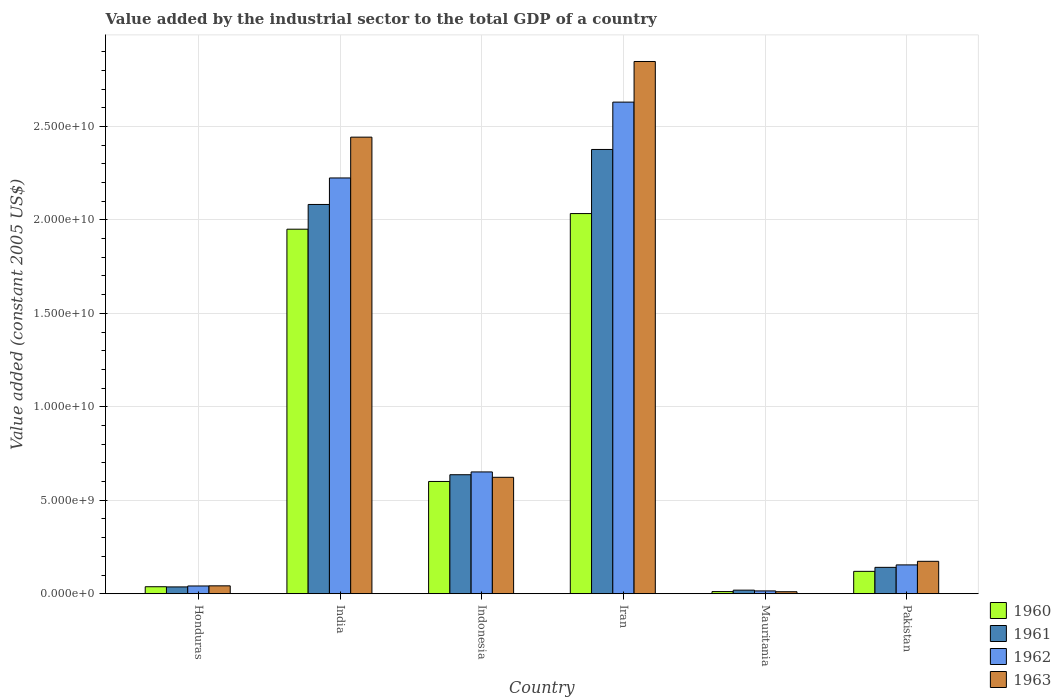How many different coloured bars are there?
Your response must be concise. 4. What is the label of the 3rd group of bars from the left?
Make the answer very short. Indonesia. What is the value added by the industrial sector in 1962 in India?
Keep it short and to the point. 2.22e+1. Across all countries, what is the maximum value added by the industrial sector in 1962?
Provide a succinct answer. 2.63e+1. Across all countries, what is the minimum value added by the industrial sector in 1960?
Give a very brief answer. 1.15e+08. In which country was the value added by the industrial sector in 1960 maximum?
Ensure brevity in your answer.  Iran. In which country was the value added by the industrial sector in 1962 minimum?
Your response must be concise. Mauritania. What is the total value added by the industrial sector in 1961 in the graph?
Give a very brief answer. 5.29e+1. What is the difference between the value added by the industrial sector in 1961 in India and that in Mauritania?
Provide a succinct answer. 2.06e+1. What is the difference between the value added by the industrial sector in 1962 in India and the value added by the industrial sector in 1961 in Honduras?
Ensure brevity in your answer.  2.19e+1. What is the average value added by the industrial sector in 1960 per country?
Offer a terse response. 7.92e+09. What is the difference between the value added by the industrial sector of/in 1961 and value added by the industrial sector of/in 1963 in Honduras?
Your response must be concise. -5.72e+07. What is the ratio of the value added by the industrial sector in 1962 in Iran to that in Mauritania?
Ensure brevity in your answer.  173.84. What is the difference between the highest and the second highest value added by the industrial sector in 1960?
Provide a short and direct response. -1.43e+1. What is the difference between the highest and the lowest value added by the industrial sector in 1961?
Ensure brevity in your answer.  2.36e+1. Is the sum of the value added by the industrial sector in 1960 in India and Pakistan greater than the maximum value added by the industrial sector in 1963 across all countries?
Your response must be concise. No. Is it the case that in every country, the sum of the value added by the industrial sector in 1963 and value added by the industrial sector in 1962 is greater than the sum of value added by the industrial sector in 1960 and value added by the industrial sector in 1961?
Give a very brief answer. No. What does the 1st bar from the right in Iran represents?
Your answer should be very brief. 1963. Is it the case that in every country, the sum of the value added by the industrial sector in 1960 and value added by the industrial sector in 1961 is greater than the value added by the industrial sector in 1963?
Your answer should be very brief. Yes. Are all the bars in the graph horizontal?
Your answer should be very brief. No. What is the difference between two consecutive major ticks on the Y-axis?
Ensure brevity in your answer.  5.00e+09. Are the values on the major ticks of Y-axis written in scientific E-notation?
Offer a very short reply. Yes. How are the legend labels stacked?
Offer a terse response. Vertical. What is the title of the graph?
Make the answer very short. Value added by the industrial sector to the total GDP of a country. Does "2011" appear as one of the legend labels in the graph?
Provide a succinct answer. No. What is the label or title of the X-axis?
Your response must be concise. Country. What is the label or title of the Y-axis?
Ensure brevity in your answer.  Value added (constant 2005 US$). What is the Value added (constant 2005 US$) in 1960 in Honduras?
Make the answer very short. 3.75e+08. What is the Value added (constant 2005 US$) in 1961 in Honduras?
Keep it short and to the point. 3.66e+08. What is the Value added (constant 2005 US$) of 1962 in Honduras?
Offer a terse response. 4.16e+08. What is the Value added (constant 2005 US$) in 1963 in Honduras?
Give a very brief answer. 4.23e+08. What is the Value added (constant 2005 US$) in 1960 in India?
Your answer should be compact. 1.95e+1. What is the Value added (constant 2005 US$) of 1961 in India?
Ensure brevity in your answer.  2.08e+1. What is the Value added (constant 2005 US$) of 1962 in India?
Ensure brevity in your answer.  2.22e+1. What is the Value added (constant 2005 US$) of 1963 in India?
Ensure brevity in your answer.  2.44e+1. What is the Value added (constant 2005 US$) of 1960 in Indonesia?
Your response must be concise. 6.01e+09. What is the Value added (constant 2005 US$) in 1961 in Indonesia?
Your answer should be very brief. 6.37e+09. What is the Value added (constant 2005 US$) in 1962 in Indonesia?
Offer a terse response. 6.52e+09. What is the Value added (constant 2005 US$) in 1963 in Indonesia?
Ensure brevity in your answer.  6.23e+09. What is the Value added (constant 2005 US$) in 1960 in Iran?
Your answer should be very brief. 2.03e+1. What is the Value added (constant 2005 US$) of 1961 in Iran?
Make the answer very short. 2.38e+1. What is the Value added (constant 2005 US$) of 1962 in Iran?
Offer a very short reply. 2.63e+1. What is the Value added (constant 2005 US$) in 1963 in Iran?
Give a very brief answer. 2.85e+1. What is the Value added (constant 2005 US$) of 1960 in Mauritania?
Provide a short and direct response. 1.15e+08. What is the Value added (constant 2005 US$) of 1961 in Mauritania?
Offer a very short reply. 1.92e+08. What is the Value added (constant 2005 US$) in 1962 in Mauritania?
Your answer should be compact. 1.51e+08. What is the Value added (constant 2005 US$) of 1963 in Mauritania?
Ensure brevity in your answer.  1.08e+08. What is the Value added (constant 2005 US$) in 1960 in Pakistan?
Make the answer very short. 1.20e+09. What is the Value added (constant 2005 US$) in 1961 in Pakistan?
Your response must be concise. 1.41e+09. What is the Value added (constant 2005 US$) of 1962 in Pakistan?
Your answer should be very brief. 1.54e+09. What is the Value added (constant 2005 US$) in 1963 in Pakistan?
Your answer should be very brief. 1.74e+09. Across all countries, what is the maximum Value added (constant 2005 US$) in 1960?
Your response must be concise. 2.03e+1. Across all countries, what is the maximum Value added (constant 2005 US$) in 1961?
Your answer should be compact. 2.38e+1. Across all countries, what is the maximum Value added (constant 2005 US$) in 1962?
Offer a very short reply. 2.63e+1. Across all countries, what is the maximum Value added (constant 2005 US$) of 1963?
Give a very brief answer. 2.85e+1. Across all countries, what is the minimum Value added (constant 2005 US$) in 1960?
Your response must be concise. 1.15e+08. Across all countries, what is the minimum Value added (constant 2005 US$) of 1961?
Offer a terse response. 1.92e+08. Across all countries, what is the minimum Value added (constant 2005 US$) of 1962?
Ensure brevity in your answer.  1.51e+08. Across all countries, what is the minimum Value added (constant 2005 US$) of 1963?
Provide a short and direct response. 1.08e+08. What is the total Value added (constant 2005 US$) of 1960 in the graph?
Make the answer very short. 4.75e+1. What is the total Value added (constant 2005 US$) of 1961 in the graph?
Give a very brief answer. 5.29e+1. What is the total Value added (constant 2005 US$) in 1962 in the graph?
Your response must be concise. 5.72e+1. What is the total Value added (constant 2005 US$) of 1963 in the graph?
Give a very brief answer. 6.14e+1. What is the difference between the Value added (constant 2005 US$) in 1960 in Honduras and that in India?
Your answer should be very brief. -1.91e+1. What is the difference between the Value added (constant 2005 US$) in 1961 in Honduras and that in India?
Your answer should be very brief. -2.05e+1. What is the difference between the Value added (constant 2005 US$) of 1962 in Honduras and that in India?
Keep it short and to the point. -2.18e+1. What is the difference between the Value added (constant 2005 US$) in 1963 in Honduras and that in India?
Provide a short and direct response. -2.40e+1. What is the difference between the Value added (constant 2005 US$) in 1960 in Honduras and that in Indonesia?
Make the answer very short. -5.63e+09. What is the difference between the Value added (constant 2005 US$) of 1961 in Honduras and that in Indonesia?
Provide a succinct answer. -6.00e+09. What is the difference between the Value added (constant 2005 US$) of 1962 in Honduras and that in Indonesia?
Your response must be concise. -6.10e+09. What is the difference between the Value added (constant 2005 US$) of 1963 in Honduras and that in Indonesia?
Provide a short and direct response. -5.81e+09. What is the difference between the Value added (constant 2005 US$) in 1960 in Honduras and that in Iran?
Your response must be concise. -2.00e+1. What is the difference between the Value added (constant 2005 US$) of 1961 in Honduras and that in Iran?
Ensure brevity in your answer.  -2.34e+1. What is the difference between the Value added (constant 2005 US$) in 1962 in Honduras and that in Iran?
Offer a very short reply. -2.59e+1. What is the difference between the Value added (constant 2005 US$) in 1963 in Honduras and that in Iran?
Your answer should be compact. -2.81e+1. What is the difference between the Value added (constant 2005 US$) in 1960 in Honduras and that in Mauritania?
Your answer should be compact. 2.60e+08. What is the difference between the Value added (constant 2005 US$) in 1961 in Honduras and that in Mauritania?
Provide a short and direct response. 1.74e+08. What is the difference between the Value added (constant 2005 US$) of 1962 in Honduras and that in Mauritania?
Provide a short and direct response. 2.65e+08. What is the difference between the Value added (constant 2005 US$) of 1963 in Honduras and that in Mauritania?
Offer a terse response. 3.15e+08. What is the difference between the Value added (constant 2005 US$) in 1960 in Honduras and that in Pakistan?
Your answer should be very brief. -8.23e+08. What is the difference between the Value added (constant 2005 US$) of 1961 in Honduras and that in Pakistan?
Provide a succinct answer. -1.05e+09. What is the difference between the Value added (constant 2005 US$) of 1962 in Honduras and that in Pakistan?
Give a very brief answer. -1.13e+09. What is the difference between the Value added (constant 2005 US$) of 1963 in Honduras and that in Pakistan?
Make the answer very short. -1.31e+09. What is the difference between the Value added (constant 2005 US$) of 1960 in India and that in Indonesia?
Keep it short and to the point. 1.35e+1. What is the difference between the Value added (constant 2005 US$) in 1961 in India and that in Indonesia?
Your response must be concise. 1.45e+1. What is the difference between the Value added (constant 2005 US$) in 1962 in India and that in Indonesia?
Offer a terse response. 1.57e+1. What is the difference between the Value added (constant 2005 US$) in 1963 in India and that in Indonesia?
Provide a short and direct response. 1.82e+1. What is the difference between the Value added (constant 2005 US$) of 1960 in India and that in Iran?
Ensure brevity in your answer.  -8.36e+08. What is the difference between the Value added (constant 2005 US$) of 1961 in India and that in Iran?
Make the answer very short. -2.94e+09. What is the difference between the Value added (constant 2005 US$) of 1962 in India and that in Iran?
Ensure brevity in your answer.  -4.06e+09. What is the difference between the Value added (constant 2005 US$) of 1963 in India and that in Iran?
Give a very brief answer. -4.05e+09. What is the difference between the Value added (constant 2005 US$) of 1960 in India and that in Mauritania?
Offer a terse response. 1.94e+1. What is the difference between the Value added (constant 2005 US$) in 1961 in India and that in Mauritania?
Provide a short and direct response. 2.06e+1. What is the difference between the Value added (constant 2005 US$) in 1962 in India and that in Mauritania?
Keep it short and to the point. 2.21e+1. What is the difference between the Value added (constant 2005 US$) in 1963 in India and that in Mauritania?
Offer a very short reply. 2.43e+1. What is the difference between the Value added (constant 2005 US$) of 1960 in India and that in Pakistan?
Ensure brevity in your answer.  1.83e+1. What is the difference between the Value added (constant 2005 US$) in 1961 in India and that in Pakistan?
Your answer should be very brief. 1.94e+1. What is the difference between the Value added (constant 2005 US$) of 1962 in India and that in Pakistan?
Provide a short and direct response. 2.07e+1. What is the difference between the Value added (constant 2005 US$) of 1963 in India and that in Pakistan?
Provide a succinct answer. 2.27e+1. What is the difference between the Value added (constant 2005 US$) in 1960 in Indonesia and that in Iran?
Your answer should be very brief. -1.43e+1. What is the difference between the Value added (constant 2005 US$) of 1961 in Indonesia and that in Iran?
Your answer should be compact. -1.74e+1. What is the difference between the Value added (constant 2005 US$) of 1962 in Indonesia and that in Iran?
Provide a succinct answer. -1.98e+1. What is the difference between the Value added (constant 2005 US$) in 1963 in Indonesia and that in Iran?
Give a very brief answer. -2.22e+1. What is the difference between the Value added (constant 2005 US$) in 1960 in Indonesia and that in Mauritania?
Keep it short and to the point. 5.89e+09. What is the difference between the Value added (constant 2005 US$) of 1961 in Indonesia and that in Mauritania?
Your answer should be compact. 6.17e+09. What is the difference between the Value added (constant 2005 US$) in 1962 in Indonesia and that in Mauritania?
Provide a succinct answer. 6.37e+09. What is the difference between the Value added (constant 2005 US$) in 1963 in Indonesia and that in Mauritania?
Offer a very short reply. 6.12e+09. What is the difference between the Value added (constant 2005 US$) in 1960 in Indonesia and that in Pakistan?
Your answer should be very brief. 4.81e+09. What is the difference between the Value added (constant 2005 US$) of 1961 in Indonesia and that in Pakistan?
Offer a terse response. 4.96e+09. What is the difference between the Value added (constant 2005 US$) in 1962 in Indonesia and that in Pakistan?
Ensure brevity in your answer.  4.97e+09. What is the difference between the Value added (constant 2005 US$) of 1963 in Indonesia and that in Pakistan?
Provide a short and direct response. 4.49e+09. What is the difference between the Value added (constant 2005 US$) of 1960 in Iran and that in Mauritania?
Your response must be concise. 2.02e+1. What is the difference between the Value added (constant 2005 US$) of 1961 in Iran and that in Mauritania?
Provide a succinct answer. 2.36e+1. What is the difference between the Value added (constant 2005 US$) in 1962 in Iran and that in Mauritania?
Provide a succinct answer. 2.62e+1. What is the difference between the Value added (constant 2005 US$) in 1963 in Iran and that in Mauritania?
Offer a terse response. 2.84e+1. What is the difference between the Value added (constant 2005 US$) of 1960 in Iran and that in Pakistan?
Ensure brevity in your answer.  1.91e+1. What is the difference between the Value added (constant 2005 US$) in 1961 in Iran and that in Pakistan?
Keep it short and to the point. 2.24e+1. What is the difference between the Value added (constant 2005 US$) of 1962 in Iran and that in Pakistan?
Keep it short and to the point. 2.48e+1. What is the difference between the Value added (constant 2005 US$) of 1963 in Iran and that in Pakistan?
Offer a very short reply. 2.67e+1. What is the difference between the Value added (constant 2005 US$) of 1960 in Mauritania and that in Pakistan?
Ensure brevity in your answer.  -1.08e+09. What is the difference between the Value added (constant 2005 US$) of 1961 in Mauritania and that in Pakistan?
Your response must be concise. -1.22e+09. What is the difference between the Value added (constant 2005 US$) of 1962 in Mauritania and that in Pakistan?
Keep it short and to the point. -1.39e+09. What is the difference between the Value added (constant 2005 US$) of 1963 in Mauritania and that in Pakistan?
Offer a terse response. -1.63e+09. What is the difference between the Value added (constant 2005 US$) in 1960 in Honduras and the Value added (constant 2005 US$) in 1961 in India?
Keep it short and to the point. -2.05e+1. What is the difference between the Value added (constant 2005 US$) in 1960 in Honduras and the Value added (constant 2005 US$) in 1962 in India?
Provide a succinct answer. -2.19e+1. What is the difference between the Value added (constant 2005 US$) in 1960 in Honduras and the Value added (constant 2005 US$) in 1963 in India?
Ensure brevity in your answer.  -2.41e+1. What is the difference between the Value added (constant 2005 US$) in 1961 in Honduras and the Value added (constant 2005 US$) in 1962 in India?
Provide a short and direct response. -2.19e+1. What is the difference between the Value added (constant 2005 US$) in 1961 in Honduras and the Value added (constant 2005 US$) in 1963 in India?
Offer a terse response. -2.41e+1. What is the difference between the Value added (constant 2005 US$) in 1962 in Honduras and the Value added (constant 2005 US$) in 1963 in India?
Provide a short and direct response. -2.40e+1. What is the difference between the Value added (constant 2005 US$) of 1960 in Honduras and the Value added (constant 2005 US$) of 1961 in Indonesia?
Ensure brevity in your answer.  -5.99e+09. What is the difference between the Value added (constant 2005 US$) of 1960 in Honduras and the Value added (constant 2005 US$) of 1962 in Indonesia?
Provide a short and direct response. -6.14e+09. What is the difference between the Value added (constant 2005 US$) of 1960 in Honduras and the Value added (constant 2005 US$) of 1963 in Indonesia?
Your answer should be compact. -5.85e+09. What is the difference between the Value added (constant 2005 US$) in 1961 in Honduras and the Value added (constant 2005 US$) in 1962 in Indonesia?
Your response must be concise. -6.15e+09. What is the difference between the Value added (constant 2005 US$) in 1961 in Honduras and the Value added (constant 2005 US$) in 1963 in Indonesia?
Offer a terse response. -5.86e+09. What is the difference between the Value added (constant 2005 US$) of 1962 in Honduras and the Value added (constant 2005 US$) of 1963 in Indonesia?
Give a very brief answer. -5.81e+09. What is the difference between the Value added (constant 2005 US$) in 1960 in Honduras and the Value added (constant 2005 US$) in 1961 in Iran?
Give a very brief answer. -2.34e+1. What is the difference between the Value added (constant 2005 US$) in 1960 in Honduras and the Value added (constant 2005 US$) in 1962 in Iran?
Provide a short and direct response. -2.59e+1. What is the difference between the Value added (constant 2005 US$) in 1960 in Honduras and the Value added (constant 2005 US$) in 1963 in Iran?
Provide a succinct answer. -2.81e+1. What is the difference between the Value added (constant 2005 US$) of 1961 in Honduras and the Value added (constant 2005 US$) of 1962 in Iran?
Give a very brief answer. -2.59e+1. What is the difference between the Value added (constant 2005 US$) in 1961 in Honduras and the Value added (constant 2005 US$) in 1963 in Iran?
Provide a short and direct response. -2.81e+1. What is the difference between the Value added (constant 2005 US$) in 1962 in Honduras and the Value added (constant 2005 US$) in 1963 in Iran?
Give a very brief answer. -2.81e+1. What is the difference between the Value added (constant 2005 US$) in 1960 in Honduras and the Value added (constant 2005 US$) in 1961 in Mauritania?
Keep it short and to the point. 1.83e+08. What is the difference between the Value added (constant 2005 US$) of 1960 in Honduras and the Value added (constant 2005 US$) of 1962 in Mauritania?
Give a very brief answer. 2.24e+08. What is the difference between the Value added (constant 2005 US$) in 1960 in Honduras and the Value added (constant 2005 US$) in 1963 in Mauritania?
Provide a short and direct response. 2.67e+08. What is the difference between the Value added (constant 2005 US$) in 1961 in Honduras and the Value added (constant 2005 US$) in 1962 in Mauritania?
Provide a succinct answer. 2.15e+08. What is the difference between the Value added (constant 2005 US$) in 1961 in Honduras and the Value added (constant 2005 US$) in 1963 in Mauritania?
Your answer should be very brief. 2.58e+08. What is the difference between the Value added (constant 2005 US$) of 1962 in Honduras and the Value added (constant 2005 US$) of 1963 in Mauritania?
Your answer should be compact. 3.08e+08. What is the difference between the Value added (constant 2005 US$) in 1960 in Honduras and the Value added (constant 2005 US$) in 1961 in Pakistan?
Offer a terse response. -1.04e+09. What is the difference between the Value added (constant 2005 US$) in 1960 in Honduras and the Value added (constant 2005 US$) in 1962 in Pakistan?
Provide a short and direct response. -1.17e+09. What is the difference between the Value added (constant 2005 US$) in 1960 in Honduras and the Value added (constant 2005 US$) in 1963 in Pakistan?
Give a very brief answer. -1.36e+09. What is the difference between the Value added (constant 2005 US$) of 1961 in Honduras and the Value added (constant 2005 US$) of 1962 in Pakistan?
Your response must be concise. -1.18e+09. What is the difference between the Value added (constant 2005 US$) of 1961 in Honduras and the Value added (constant 2005 US$) of 1963 in Pakistan?
Give a very brief answer. -1.37e+09. What is the difference between the Value added (constant 2005 US$) in 1962 in Honduras and the Value added (constant 2005 US$) in 1963 in Pakistan?
Give a very brief answer. -1.32e+09. What is the difference between the Value added (constant 2005 US$) in 1960 in India and the Value added (constant 2005 US$) in 1961 in Indonesia?
Offer a very short reply. 1.31e+1. What is the difference between the Value added (constant 2005 US$) of 1960 in India and the Value added (constant 2005 US$) of 1962 in Indonesia?
Provide a short and direct response. 1.30e+1. What is the difference between the Value added (constant 2005 US$) of 1960 in India and the Value added (constant 2005 US$) of 1963 in Indonesia?
Make the answer very short. 1.33e+1. What is the difference between the Value added (constant 2005 US$) of 1961 in India and the Value added (constant 2005 US$) of 1962 in Indonesia?
Your answer should be compact. 1.43e+1. What is the difference between the Value added (constant 2005 US$) in 1961 in India and the Value added (constant 2005 US$) in 1963 in Indonesia?
Keep it short and to the point. 1.46e+1. What is the difference between the Value added (constant 2005 US$) of 1962 in India and the Value added (constant 2005 US$) of 1963 in Indonesia?
Ensure brevity in your answer.  1.60e+1. What is the difference between the Value added (constant 2005 US$) of 1960 in India and the Value added (constant 2005 US$) of 1961 in Iran?
Make the answer very short. -4.27e+09. What is the difference between the Value added (constant 2005 US$) in 1960 in India and the Value added (constant 2005 US$) in 1962 in Iran?
Offer a terse response. -6.80e+09. What is the difference between the Value added (constant 2005 US$) in 1960 in India and the Value added (constant 2005 US$) in 1963 in Iran?
Your answer should be very brief. -8.97e+09. What is the difference between the Value added (constant 2005 US$) in 1961 in India and the Value added (constant 2005 US$) in 1962 in Iran?
Give a very brief answer. -5.48e+09. What is the difference between the Value added (constant 2005 US$) in 1961 in India and the Value added (constant 2005 US$) in 1963 in Iran?
Your answer should be very brief. -7.65e+09. What is the difference between the Value added (constant 2005 US$) in 1962 in India and the Value added (constant 2005 US$) in 1963 in Iran?
Keep it short and to the point. -6.23e+09. What is the difference between the Value added (constant 2005 US$) in 1960 in India and the Value added (constant 2005 US$) in 1961 in Mauritania?
Your answer should be compact. 1.93e+1. What is the difference between the Value added (constant 2005 US$) in 1960 in India and the Value added (constant 2005 US$) in 1962 in Mauritania?
Give a very brief answer. 1.94e+1. What is the difference between the Value added (constant 2005 US$) of 1960 in India and the Value added (constant 2005 US$) of 1963 in Mauritania?
Offer a very short reply. 1.94e+1. What is the difference between the Value added (constant 2005 US$) of 1961 in India and the Value added (constant 2005 US$) of 1962 in Mauritania?
Give a very brief answer. 2.07e+1. What is the difference between the Value added (constant 2005 US$) in 1961 in India and the Value added (constant 2005 US$) in 1963 in Mauritania?
Provide a short and direct response. 2.07e+1. What is the difference between the Value added (constant 2005 US$) of 1962 in India and the Value added (constant 2005 US$) of 1963 in Mauritania?
Your answer should be very brief. 2.21e+1. What is the difference between the Value added (constant 2005 US$) of 1960 in India and the Value added (constant 2005 US$) of 1961 in Pakistan?
Provide a short and direct response. 1.81e+1. What is the difference between the Value added (constant 2005 US$) in 1960 in India and the Value added (constant 2005 US$) in 1962 in Pakistan?
Your answer should be very brief. 1.80e+1. What is the difference between the Value added (constant 2005 US$) in 1960 in India and the Value added (constant 2005 US$) in 1963 in Pakistan?
Make the answer very short. 1.78e+1. What is the difference between the Value added (constant 2005 US$) of 1961 in India and the Value added (constant 2005 US$) of 1962 in Pakistan?
Make the answer very short. 1.93e+1. What is the difference between the Value added (constant 2005 US$) of 1961 in India and the Value added (constant 2005 US$) of 1963 in Pakistan?
Keep it short and to the point. 1.91e+1. What is the difference between the Value added (constant 2005 US$) in 1962 in India and the Value added (constant 2005 US$) in 1963 in Pakistan?
Provide a succinct answer. 2.05e+1. What is the difference between the Value added (constant 2005 US$) of 1960 in Indonesia and the Value added (constant 2005 US$) of 1961 in Iran?
Your response must be concise. -1.78e+1. What is the difference between the Value added (constant 2005 US$) of 1960 in Indonesia and the Value added (constant 2005 US$) of 1962 in Iran?
Provide a succinct answer. -2.03e+1. What is the difference between the Value added (constant 2005 US$) in 1960 in Indonesia and the Value added (constant 2005 US$) in 1963 in Iran?
Give a very brief answer. -2.25e+1. What is the difference between the Value added (constant 2005 US$) of 1961 in Indonesia and the Value added (constant 2005 US$) of 1962 in Iran?
Provide a short and direct response. -1.99e+1. What is the difference between the Value added (constant 2005 US$) of 1961 in Indonesia and the Value added (constant 2005 US$) of 1963 in Iran?
Offer a terse response. -2.21e+1. What is the difference between the Value added (constant 2005 US$) in 1962 in Indonesia and the Value added (constant 2005 US$) in 1963 in Iran?
Provide a short and direct response. -2.20e+1. What is the difference between the Value added (constant 2005 US$) of 1960 in Indonesia and the Value added (constant 2005 US$) of 1961 in Mauritania?
Give a very brief answer. 5.81e+09. What is the difference between the Value added (constant 2005 US$) of 1960 in Indonesia and the Value added (constant 2005 US$) of 1962 in Mauritania?
Keep it short and to the point. 5.86e+09. What is the difference between the Value added (constant 2005 US$) of 1960 in Indonesia and the Value added (constant 2005 US$) of 1963 in Mauritania?
Your response must be concise. 5.90e+09. What is the difference between the Value added (constant 2005 US$) in 1961 in Indonesia and the Value added (constant 2005 US$) in 1962 in Mauritania?
Keep it short and to the point. 6.22e+09. What is the difference between the Value added (constant 2005 US$) in 1961 in Indonesia and the Value added (constant 2005 US$) in 1963 in Mauritania?
Your answer should be compact. 6.26e+09. What is the difference between the Value added (constant 2005 US$) of 1962 in Indonesia and the Value added (constant 2005 US$) of 1963 in Mauritania?
Your answer should be very brief. 6.41e+09. What is the difference between the Value added (constant 2005 US$) in 1960 in Indonesia and the Value added (constant 2005 US$) in 1961 in Pakistan?
Make the answer very short. 4.60e+09. What is the difference between the Value added (constant 2005 US$) of 1960 in Indonesia and the Value added (constant 2005 US$) of 1962 in Pakistan?
Ensure brevity in your answer.  4.46e+09. What is the difference between the Value added (constant 2005 US$) of 1960 in Indonesia and the Value added (constant 2005 US$) of 1963 in Pakistan?
Provide a short and direct response. 4.27e+09. What is the difference between the Value added (constant 2005 US$) in 1961 in Indonesia and the Value added (constant 2005 US$) in 1962 in Pakistan?
Your answer should be very brief. 4.82e+09. What is the difference between the Value added (constant 2005 US$) of 1961 in Indonesia and the Value added (constant 2005 US$) of 1963 in Pakistan?
Keep it short and to the point. 4.63e+09. What is the difference between the Value added (constant 2005 US$) in 1962 in Indonesia and the Value added (constant 2005 US$) in 1963 in Pakistan?
Offer a very short reply. 4.78e+09. What is the difference between the Value added (constant 2005 US$) in 1960 in Iran and the Value added (constant 2005 US$) in 1961 in Mauritania?
Offer a terse response. 2.01e+1. What is the difference between the Value added (constant 2005 US$) in 1960 in Iran and the Value added (constant 2005 US$) in 1962 in Mauritania?
Your answer should be very brief. 2.02e+1. What is the difference between the Value added (constant 2005 US$) of 1960 in Iran and the Value added (constant 2005 US$) of 1963 in Mauritania?
Offer a terse response. 2.02e+1. What is the difference between the Value added (constant 2005 US$) of 1961 in Iran and the Value added (constant 2005 US$) of 1962 in Mauritania?
Your answer should be compact. 2.36e+1. What is the difference between the Value added (constant 2005 US$) in 1961 in Iran and the Value added (constant 2005 US$) in 1963 in Mauritania?
Your answer should be compact. 2.37e+1. What is the difference between the Value added (constant 2005 US$) in 1962 in Iran and the Value added (constant 2005 US$) in 1963 in Mauritania?
Your answer should be very brief. 2.62e+1. What is the difference between the Value added (constant 2005 US$) in 1960 in Iran and the Value added (constant 2005 US$) in 1961 in Pakistan?
Offer a terse response. 1.89e+1. What is the difference between the Value added (constant 2005 US$) in 1960 in Iran and the Value added (constant 2005 US$) in 1962 in Pakistan?
Provide a succinct answer. 1.88e+1. What is the difference between the Value added (constant 2005 US$) in 1960 in Iran and the Value added (constant 2005 US$) in 1963 in Pakistan?
Ensure brevity in your answer.  1.86e+1. What is the difference between the Value added (constant 2005 US$) in 1961 in Iran and the Value added (constant 2005 US$) in 1962 in Pakistan?
Make the answer very short. 2.22e+1. What is the difference between the Value added (constant 2005 US$) of 1961 in Iran and the Value added (constant 2005 US$) of 1963 in Pakistan?
Ensure brevity in your answer.  2.20e+1. What is the difference between the Value added (constant 2005 US$) of 1962 in Iran and the Value added (constant 2005 US$) of 1963 in Pakistan?
Your answer should be compact. 2.46e+1. What is the difference between the Value added (constant 2005 US$) of 1960 in Mauritania and the Value added (constant 2005 US$) of 1961 in Pakistan?
Your answer should be compact. -1.30e+09. What is the difference between the Value added (constant 2005 US$) in 1960 in Mauritania and the Value added (constant 2005 US$) in 1962 in Pakistan?
Offer a terse response. -1.43e+09. What is the difference between the Value added (constant 2005 US$) in 1960 in Mauritania and the Value added (constant 2005 US$) in 1963 in Pakistan?
Offer a terse response. -1.62e+09. What is the difference between the Value added (constant 2005 US$) in 1961 in Mauritania and the Value added (constant 2005 US$) in 1962 in Pakistan?
Provide a succinct answer. -1.35e+09. What is the difference between the Value added (constant 2005 US$) of 1961 in Mauritania and the Value added (constant 2005 US$) of 1963 in Pakistan?
Provide a short and direct response. -1.54e+09. What is the difference between the Value added (constant 2005 US$) of 1962 in Mauritania and the Value added (constant 2005 US$) of 1963 in Pakistan?
Provide a short and direct response. -1.58e+09. What is the average Value added (constant 2005 US$) of 1960 per country?
Your response must be concise. 7.92e+09. What is the average Value added (constant 2005 US$) in 1961 per country?
Ensure brevity in your answer.  8.82e+09. What is the average Value added (constant 2005 US$) in 1962 per country?
Your answer should be very brief. 9.53e+09. What is the average Value added (constant 2005 US$) in 1963 per country?
Offer a very short reply. 1.02e+1. What is the difference between the Value added (constant 2005 US$) in 1960 and Value added (constant 2005 US$) in 1961 in Honduras?
Provide a succinct answer. 9.37e+06. What is the difference between the Value added (constant 2005 US$) of 1960 and Value added (constant 2005 US$) of 1962 in Honduras?
Give a very brief answer. -4.07e+07. What is the difference between the Value added (constant 2005 US$) of 1960 and Value added (constant 2005 US$) of 1963 in Honduras?
Offer a terse response. -4.79e+07. What is the difference between the Value added (constant 2005 US$) in 1961 and Value added (constant 2005 US$) in 1962 in Honduras?
Your answer should be very brief. -5.00e+07. What is the difference between the Value added (constant 2005 US$) of 1961 and Value added (constant 2005 US$) of 1963 in Honduras?
Provide a succinct answer. -5.72e+07. What is the difference between the Value added (constant 2005 US$) in 1962 and Value added (constant 2005 US$) in 1963 in Honduras?
Your answer should be compact. -7.19e+06. What is the difference between the Value added (constant 2005 US$) in 1960 and Value added (constant 2005 US$) in 1961 in India?
Your answer should be very brief. -1.32e+09. What is the difference between the Value added (constant 2005 US$) of 1960 and Value added (constant 2005 US$) of 1962 in India?
Your answer should be compact. -2.74e+09. What is the difference between the Value added (constant 2005 US$) in 1960 and Value added (constant 2005 US$) in 1963 in India?
Your answer should be very brief. -4.92e+09. What is the difference between the Value added (constant 2005 US$) in 1961 and Value added (constant 2005 US$) in 1962 in India?
Your answer should be very brief. -1.42e+09. What is the difference between the Value added (constant 2005 US$) in 1961 and Value added (constant 2005 US$) in 1963 in India?
Offer a terse response. -3.60e+09. What is the difference between the Value added (constant 2005 US$) of 1962 and Value added (constant 2005 US$) of 1963 in India?
Provide a succinct answer. -2.18e+09. What is the difference between the Value added (constant 2005 US$) in 1960 and Value added (constant 2005 US$) in 1961 in Indonesia?
Offer a very short reply. -3.60e+08. What is the difference between the Value added (constant 2005 US$) of 1960 and Value added (constant 2005 US$) of 1962 in Indonesia?
Offer a very short reply. -5.10e+08. What is the difference between the Value added (constant 2005 US$) in 1960 and Value added (constant 2005 US$) in 1963 in Indonesia?
Your response must be concise. -2.22e+08. What is the difference between the Value added (constant 2005 US$) in 1961 and Value added (constant 2005 US$) in 1962 in Indonesia?
Provide a short and direct response. -1.50e+08. What is the difference between the Value added (constant 2005 US$) of 1961 and Value added (constant 2005 US$) of 1963 in Indonesia?
Your response must be concise. 1.38e+08. What is the difference between the Value added (constant 2005 US$) in 1962 and Value added (constant 2005 US$) in 1963 in Indonesia?
Your response must be concise. 2.88e+08. What is the difference between the Value added (constant 2005 US$) in 1960 and Value added (constant 2005 US$) in 1961 in Iran?
Provide a succinct answer. -3.43e+09. What is the difference between the Value added (constant 2005 US$) of 1960 and Value added (constant 2005 US$) of 1962 in Iran?
Provide a succinct answer. -5.96e+09. What is the difference between the Value added (constant 2005 US$) of 1960 and Value added (constant 2005 US$) of 1963 in Iran?
Make the answer very short. -8.14e+09. What is the difference between the Value added (constant 2005 US$) of 1961 and Value added (constant 2005 US$) of 1962 in Iran?
Ensure brevity in your answer.  -2.53e+09. What is the difference between the Value added (constant 2005 US$) of 1961 and Value added (constant 2005 US$) of 1963 in Iran?
Make the answer very short. -4.71e+09. What is the difference between the Value added (constant 2005 US$) in 1962 and Value added (constant 2005 US$) in 1963 in Iran?
Ensure brevity in your answer.  -2.17e+09. What is the difference between the Value added (constant 2005 US$) in 1960 and Value added (constant 2005 US$) in 1961 in Mauritania?
Your answer should be very brief. -7.68e+07. What is the difference between the Value added (constant 2005 US$) in 1960 and Value added (constant 2005 US$) in 1962 in Mauritania?
Your answer should be very brief. -3.59e+07. What is the difference between the Value added (constant 2005 US$) of 1960 and Value added (constant 2005 US$) of 1963 in Mauritania?
Offer a very short reply. 7.13e+06. What is the difference between the Value added (constant 2005 US$) of 1961 and Value added (constant 2005 US$) of 1962 in Mauritania?
Offer a very short reply. 4.09e+07. What is the difference between the Value added (constant 2005 US$) of 1961 and Value added (constant 2005 US$) of 1963 in Mauritania?
Ensure brevity in your answer.  8.39e+07. What is the difference between the Value added (constant 2005 US$) in 1962 and Value added (constant 2005 US$) in 1963 in Mauritania?
Provide a succinct answer. 4.31e+07. What is the difference between the Value added (constant 2005 US$) of 1960 and Value added (constant 2005 US$) of 1961 in Pakistan?
Give a very brief answer. -2.14e+08. What is the difference between the Value added (constant 2005 US$) of 1960 and Value added (constant 2005 US$) of 1962 in Pakistan?
Keep it short and to the point. -3.45e+08. What is the difference between the Value added (constant 2005 US$) of 1960 and Value added (constant 2005 US$) of 1963 in Pakistan?
Provide a short and direct response. -5.37e+08. What is the difference between the Value added (constant 2005 US$) of 1961 and Value added (constant 2005 US$) of 1962 in Pakistan?
Keep it short and to the point. -1.32e+08. What is the difference between the Value added (constant 2005 US$) of 1961 and Value added (constant 2005 US$) of 1963 in Pakistan?
Your response must be concise. -3.23e+08. What is the difference between the Value added (constant 2005 US$) of 1962 and Value added (constant 2005 US$) of 1963 in Pakistan?
Your answer should be very brief. -1.92e+08. What is the ratio of the Value added (constant 2005 US$) of 1960 in Honduras to that in India?
Offer a terse response. 0.02. What is the ratio of the Value added (constant 2005 US$) in 1961 in Honduras to that in India?
Give a very brief answer. 0.02. What is the ratio of the Value added (constant 2005 US$) in 1962 in Honduras to that in India?
Ensure brevity in your answer.  0.02. What is the ratio of the Value added (constant 2005 US$) of 1963 in Honduras to that in India?
Ensure brevity in your answer.  0.02. What is the ratio of the Value added (constant 2005 US$) in 1960 in Honduras to that in Indonesia?
Keep it short and to the point. 0.06. What is the ratio of the Value added (constant 2005 US$) in 1961 in Honduras to that in Indonesia?
Offer a terse response. 0.06. What is the ratio of the Value added (constant 2005 US$) of 1962 in Honduras to that in Indonesia?
Ensure brevity in your answer.  0.06. What is the ratio of the Value added (constant 2005 US$) in 1963 in Honduras to that in Indonesia?
Provide a short and direct response. 0.07. What is the ratio of the Value added (constant 2005 US$) in 1960 in Honduras to that in Iran?
Make the answer very short. 0.02. What is the ratio of the Value added (constant 2005 US$) of 1961 in Honduras to that in Iran?
Keep it short and to the point. 0.02. What is the ratio of the Value added (constant 2005 US$) in 1962 in Honduras to that in Iran?
Make the answer very short. 0.02. What is the ratio of the Value added (constant 2005 US$) of 1963 in Honduras to that in Iran?
Provide a succinct answer. 0.01. What is the ratio of the Value added (constant 2005 US$) in 1960 in Honduras to that in Mauritania?
Offer a very short reply. 3.25. What is the ratio of the Value added (constant 2005 US$) in 1961 in Honduras to that in Mauritania?
Provide a succinct answer. 1.9. What is the ratio of the Value added (constant 2005 US$) of 1962 in Honduras to that in Mauritania?
Provide a short and direct response. 2.75. What is the ratio of the Value added (constant 2005 US$) in 1963 in Honduras to that in Mauritania?
Ensure brevity in your answer.  3.91. What is the ratio of the Value added (constant 2005 US$) of 1960 in Honduras to that in Pakistan?
Provide a short and direct response. 0.31. What is the ratio of the Value added (constant 2005 US$) of 1961 in Honduras to that in Pakistan?
Keep it short and to the point. 0.26. What is the ratio of the Value added (constant 2005 US$) in 1962 in Honduras to that in Pakistan?
Provide a short and direct response. 0.27. What is the ratio of the Value added (constant 2005 US$) of 1963 in Honduras to that in Pakistan?
Your response must be concise. 0.24. What is the ratio of the Value added (constant 2005 US$) in 1960 in India to that in Indonesia?
Provide a succinct answer. 3.25. What is the ratio of the Value added (constant 2005 US$) in 1961 in India to that in Indonesia?
Keep it short and to the point. 3.27. What is the ratio of the Value added (constant 2005 US$) in 1962 in India to that in Indonesia?
Make the answer very short. 3.41. What is the ratio of the Value added (constant 2005 US$) of 1963 in India to that in Indonesia?
Your response must be concise. 3.92. What is the ratio of the Value added (constant 2005 US$) in 1960 in India to that in Iran?
Your answer should be compact. 0.96. What is the ratio of the Value added (constant 2005 US$) in 1961 in India to that in Iran?
Keep it short and to the point. 0.88. What is the ratio of the Value added (constant 2005 US$) of 1962 in India to that in Iran?
Give a very brief answer. 0.85. What is the ratio of the Value added (constant 2005 US$) in 1963 in India to that in Iran?
Make the answer very short. 0.86. What is the ratio of the Value added (constant 2005 US$) in 1960 in India to that in Mauritania?
Offer a terse response. 169.07. What is the ratio of the Value added (constant 2005 US$) in 1961 in India to that in Mauritania?
Provide a short and direct response. 108.39. What is the ratio of the Value added (constant 2005 US$) in 1962 in India to that in Mauritania?
Make the answer very short. 147.02. What is the ratio of the Value added (constant 2005 US$) of 1963 in India to that in Mauritania?
Your answer should be compact. 225.7. What is the ratio of the Value added (constant 2005 US$) in 1960 in India to that in Pakistan?
Keep it short and to the point. 16.28. What is the ratio of the Value added (constant 2005 US$) in 1961 in India to that in Pakistan?
Provide a succinct answer. 14.75. What is the ratio of the Value added (constant 2005 US$) in 1962 in India to that in Pakistan?
Keep it short and to the point. 14.41. What is the ratio of the Value added (constant 2005 US$) of 1963 in India to that in Pakistan?
Offer a very short reply. 14.08. What is the ratio of the Value added (constant 2005 US$) of 1960 in Indonesia to that in Iran?
Your answer should be very brief. 0.3. What is the ratio of the Value added (constant 2005 US$) in 1961 in Indonesia to that in Iran?
Keep it short and to the point. 0.27. What is the ratio of the Value added (constant 2005 US$) in 1962 in Indonesia to that in Iran?
Your response must be concise. 0.25. What is the ratio of the Value added (constant 2005 US$) of 1963 in Indonesia to that in Iran?
Your answer should be compact. 0.22. What is the ratio of the Value added (constant 2005 US$) of 1960 in Indonesia to that in Mauritania?
Keep it short and to the point. 52.07. What is the ratio of the Value added (constant 2005 US$) in 1961 in Indonesia to that in Mauritania?
Offer a very short reply. 33.14. What is the ratio of the Value added (constant 2005 US$) in 1962 in Indonesia to that in Mauritania?
Keep it short and to the point. 43.07. What is the ratio of the Value added (constant 2005 US$) of 1963 in Indonesia to that in Mauritania?
Your answer should be very brief. 57.56. What is the ratio of the Value added (constant 2005 US$) of 1960 in Indonesia to that in Pakistan?
Provide a short and direct response. 5.01. What is the ratio of the Value added (constant 2005 US$) in 1961 in Indonesia to that in Pakistan?
Your response must be concise. 4.51. What is the ratio of the Value added (constant 2005 US$) of 1962 in Indonesia to that in Pakistan?
Provide a short and direct response. 4.22. What is the ratio of the Value added (constant 2005 US$) of 1963 in Indonesia to that in Pakistan?
Provide a succinct answer. 3.59. What is the ratio of the Value added (constant 2005 US$) of 1960 in Iran to that in Mauritania?
Offer a terse response. 176.32. What is the ratio of the Value added (constant 2005 US$) of 1961 in Iran to that in Mauritania?
Your answer should be compact. 123.7. What is the ratio of the Value added (constant 2005 US$) in 1962 in Iran to that in Mauritania?
Your answer should be compact. 173.84. What is the ratio of the Value added (constant 2005 US$) of 1963 in Iran to that in Mauritania?
Give a very brief answer. 263.11. What is the ratio of the Value added (constant 2005 US$) of 1960 in Iran to that in Pakistan?
Your answer should be compact. 16.98. What is the ratio of the Value added (constant 2005 US$) in 1961 in Iran to that in Pakistan?
Your answer should be compact. 16.84. What is the ratio of the Value added (constant 2005 US$) of 1962 in Iran to that in Pakistan?
Offer a very short reply. 17.04. What is the ratio of the Value added (constant 2005 US$) of 1963 in Iran to that in Pakistan?
Keep it short and to the point. 16.41. What is the ratio of the Value added (constant 2005 US$) of 1960 in Mauritania to that in Pakistan?
Provide a short and direct response. 0.1. What is the ratio of the Value added (constant 2005 US$) in 1961 in Mauritania to that in Pakistan?
Offer a very short reply. 0.14. What is the ratio of the Value added (constant 2005 US$) of 1962 in Mauritania to that in Pakistan?
Offer a very short reply. 0.1. What is the ratio of the Value added (constant 2005 US$) of 1963 in Mauritania to that in Pakistan?
Offer a very short reply. 0.06. What is the difference between the highest and the second highest Value added (constant 2005 US$) in 1960?
Make the answer very short. 8.36e+08. What is the difference between the highest and the second highest Value added (constant 2005 US$) of 1961?
Give a very brief answer. 2.94e+09. What is the difference between the highest and the second highest Value added (constant 2005 US$) in 1962?
Your answer should be very brief. 4.06e+09. What is the difference between the highest and the second highest Value added (constant 2005 US$) of 1963?
Your response must be concise. 4.05e+09. What is the difference between the highest and the lowest Value added (constant 2005 US$) in 1960?
Your answer should be very brief. 2.02e+1. What is the difference between the highest and the lowest Value added (constant 2005 US$) of 1961?
Give a very brief answer. 2.36e+1. What is the difference between the highest and the lowest Value added (constant 2005 US$) of 1962?
Offer a terse response. 2.62e+1. What is the difference between the highest and the lowest Value added (constant 2005 US$) in 1963?
Offer a very short reply. 2.84e+1. 